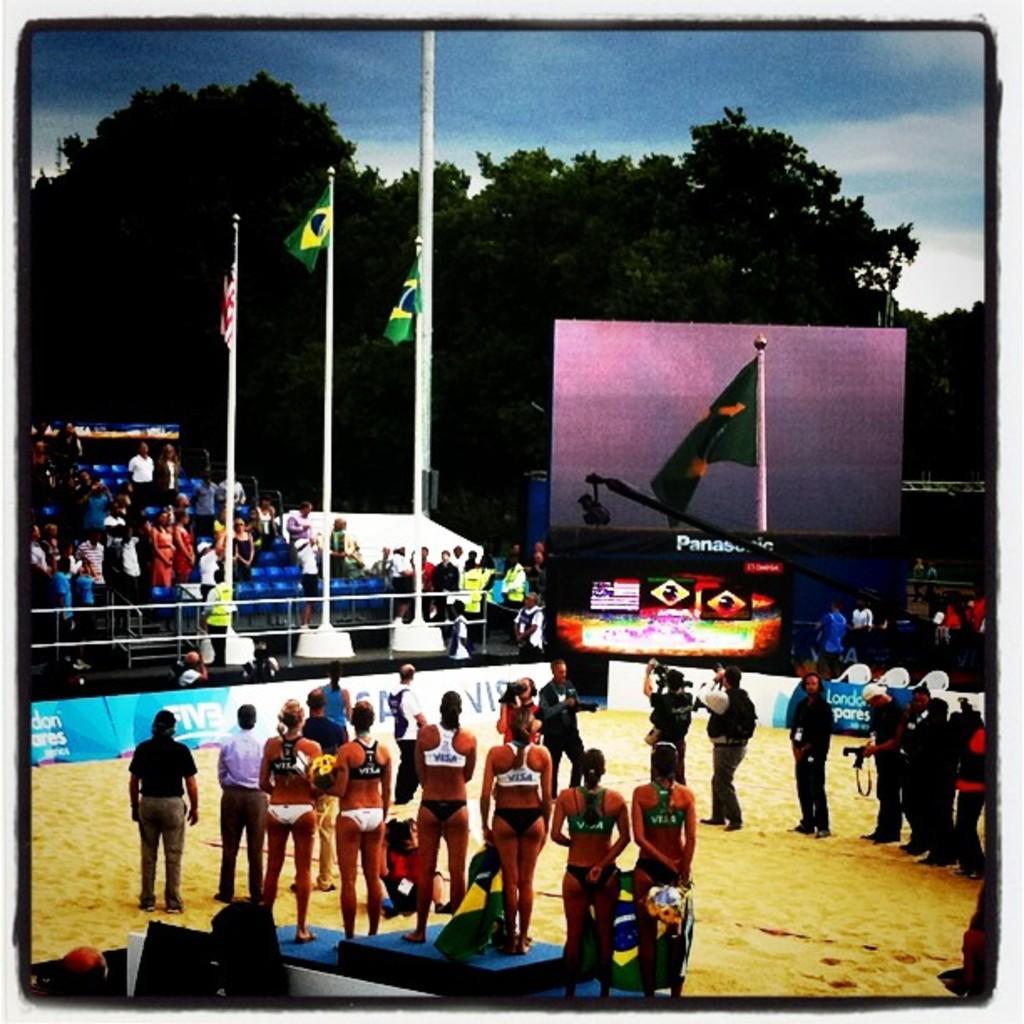Can you describe this image briefly? This is a photo and here we can see people and some are wearing sports dress and some are holding objects. In the background, there are flags and we can see a screen and there are boards, trees, banners and there is a crowd and some railings. At the top, there is sky and at the bottom, there is ground. 